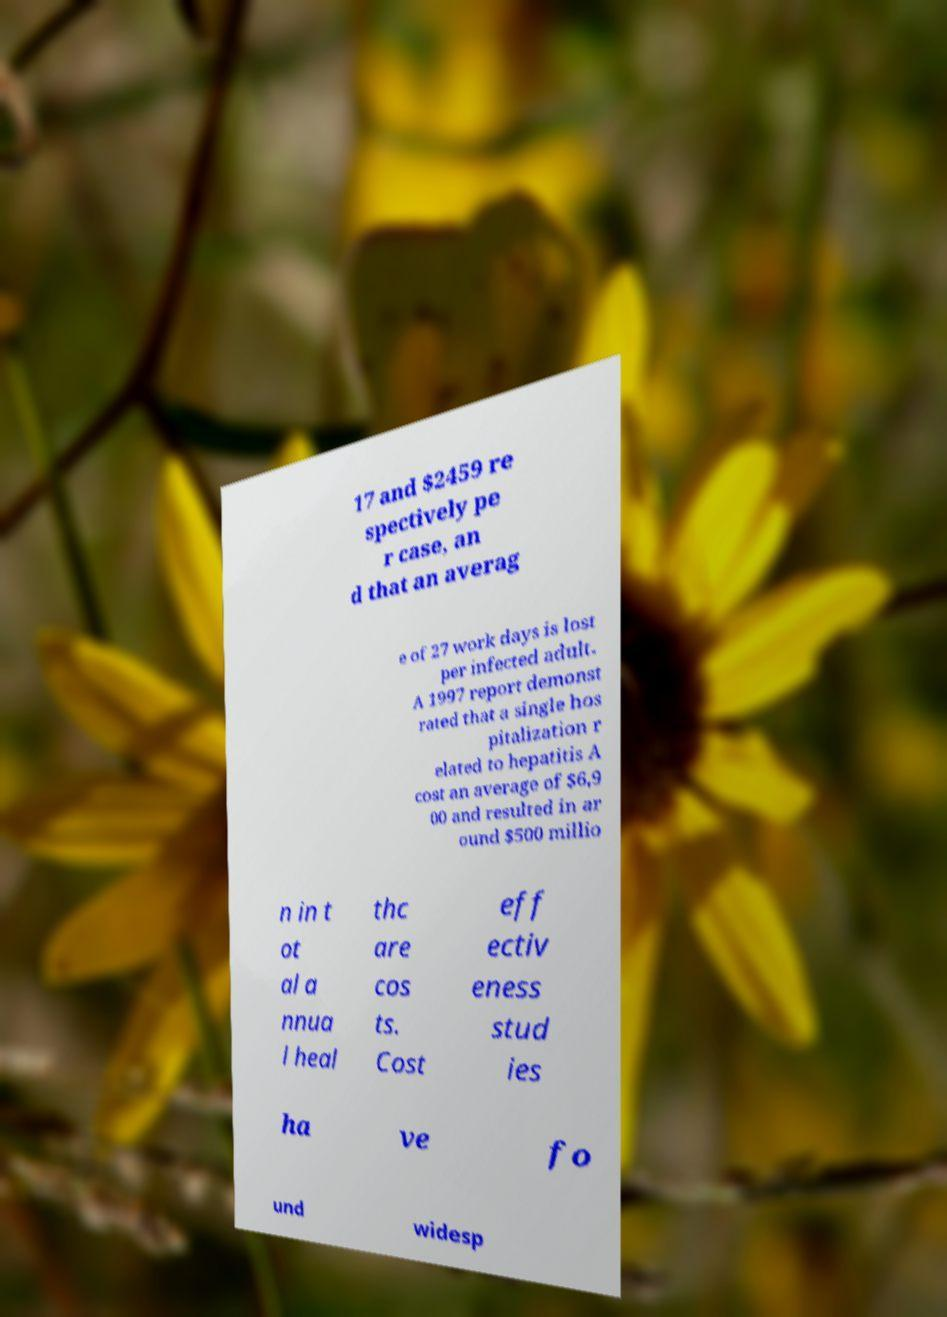For documentation purposes, I need the text within this image transcribed. Could you provide that? 17 and $2459 re spectively pe r case, an d that an averag e of 27 work days is lost per infected adult. A 1997 report demonst rated that a single hos pitalization r elated to hepatitis A cost an average of $6,9 00 and resulted in ar ound $500 millio n in t ot al a nnua l heal thc are cos ts. Cost eff ectiv eness stud ies ha ve fo und widesp 